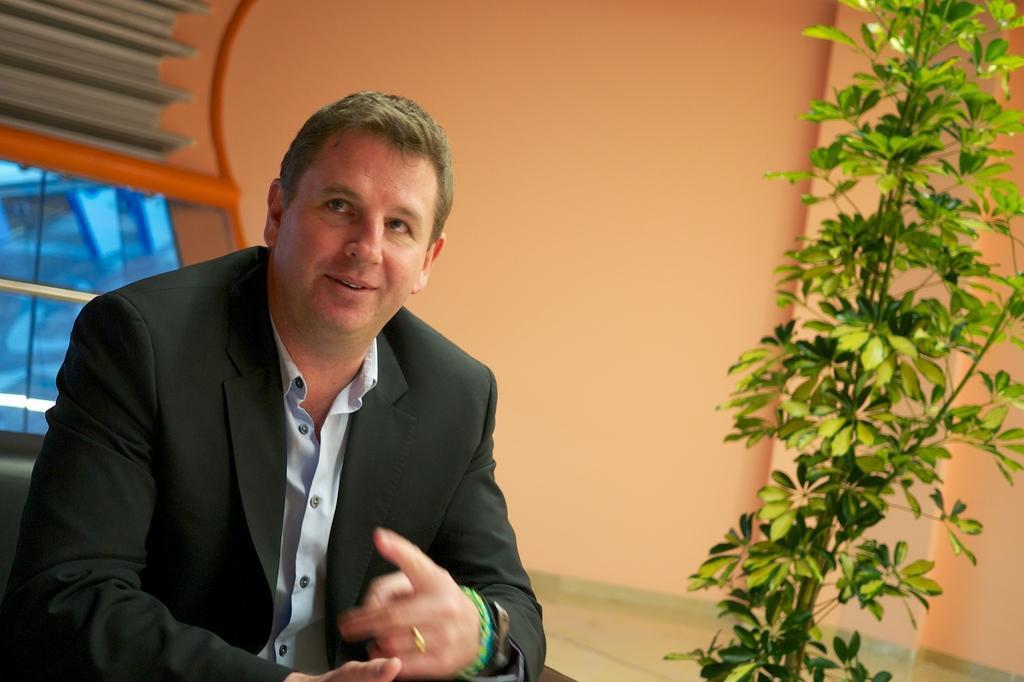Describe this image in one or two sentences. In the image I can see a person who is wearing the suit and sitting in front of the table and also I can see a plant in front of him. 